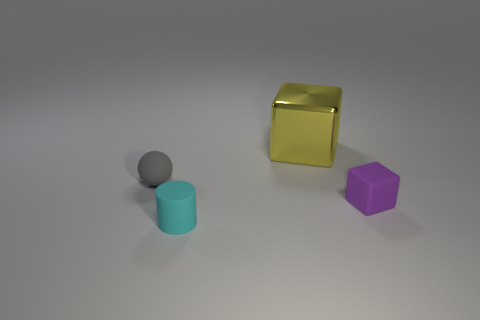Add 4 big cyan objects. How many objects exist? 8 Subtract all spheres. How many objects are left? 3 Subtract all cyan matte objects. Subtract all small purple rubber blocks. How many objects are left? 2 Add 1 spheres. How many spheres are left? 2 Add 2 red rubber balls. How many red rubber balls exist? 2 Subtract 0 purple spheres. How many objects are left? 4 